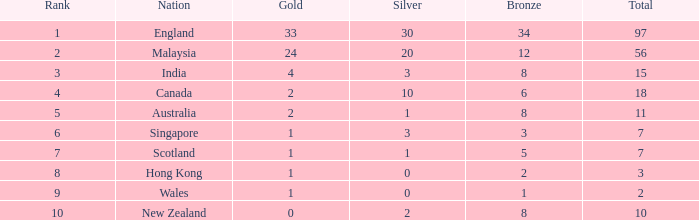What is the maximum rank a team has achieved with 1 silver and less than 5 bronze medals? None. 